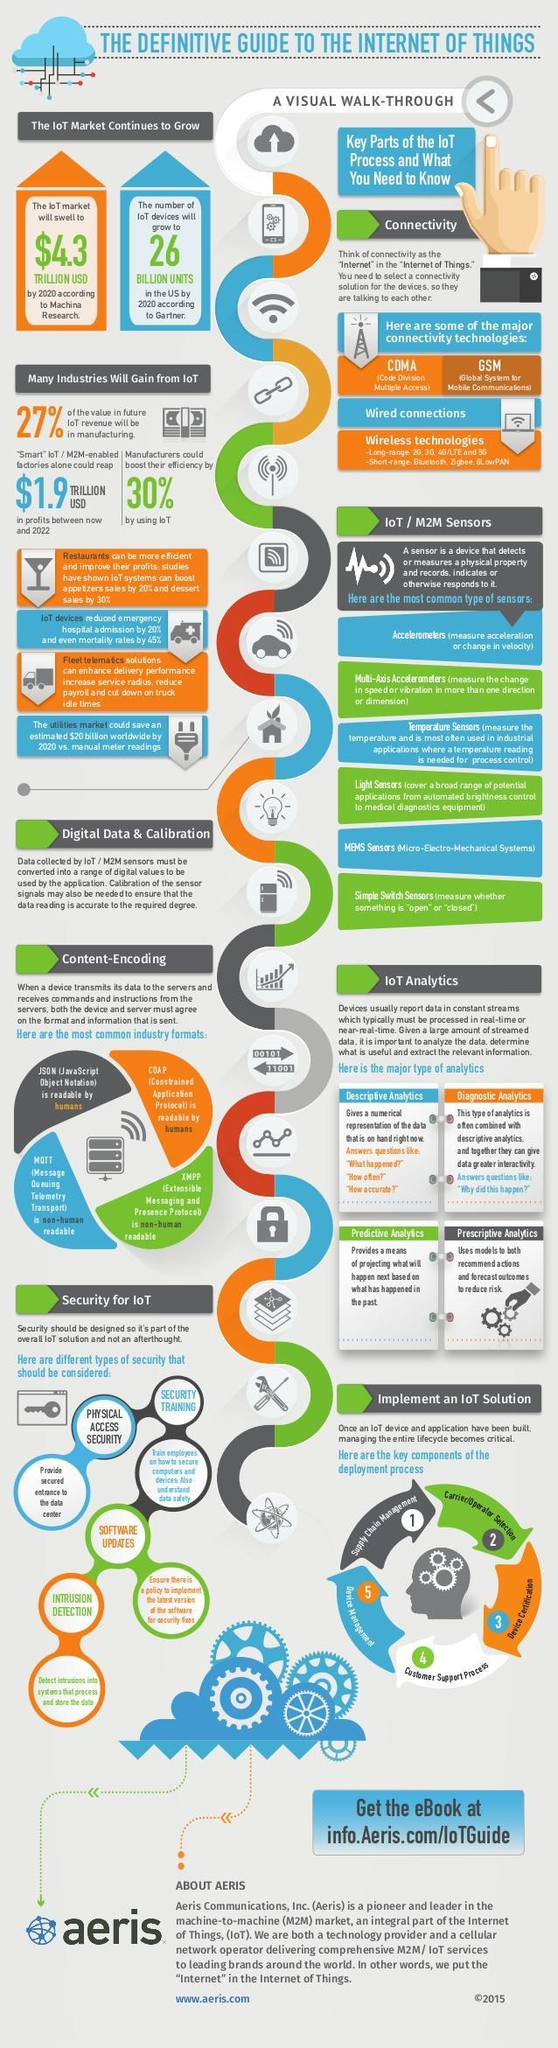What percent of growth in efficiency is obtained by manufacturers by using IoT?
Answer the question with a short phrase. 30% What will be the IoT market value by 2020 according to the Machina Research? $4.3 TRILLION USD What will be the number of IoT devices in the US by 2020 according to Gartner? 26 BILLION UNITS 